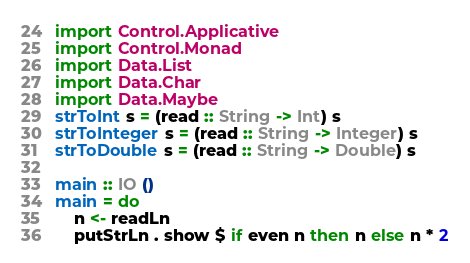<code> <loc_0><loc_0><loc_500><loc_500><_Haskell_>import Control.Applicative
import Control.Monad
import Data.List
import Data.Char
import Data.Maybe
strToInt s = (read :: String -> Int) s
strToInteger s = (read :: String -> Integer) s
strToDouble s = (read :: String -> Double) s

main :: IO ()
main = do
	n <- readLn
	putStrLn . show $ if even n then n else n * 2
</code> 